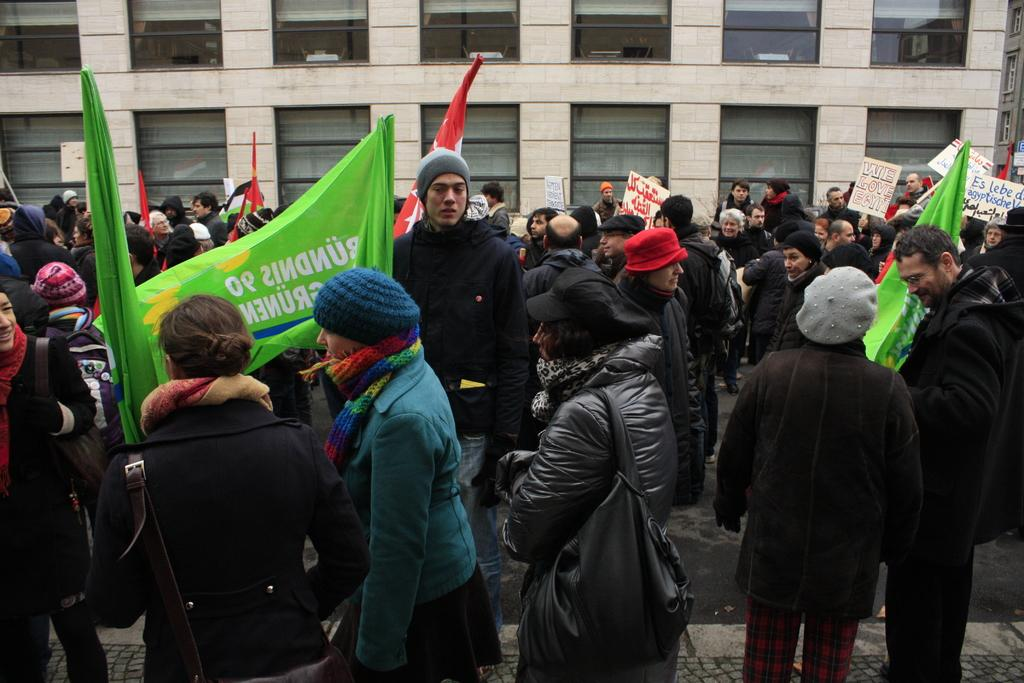What are the persons in the image holding? The persons in the image are holding flags. What can be seen in the background of the image? There is a building in the background of the image. What else are people holding in the image besides flags? There are people holding boards in the image. What type of coat is the snail wearing in the image? There is no snail or coat present in the image. Who is the son of the person holding the flag in the image? The provided facts do not mention any family relationships, so it is not possible to determine the son of the person holding the flag in the image. 